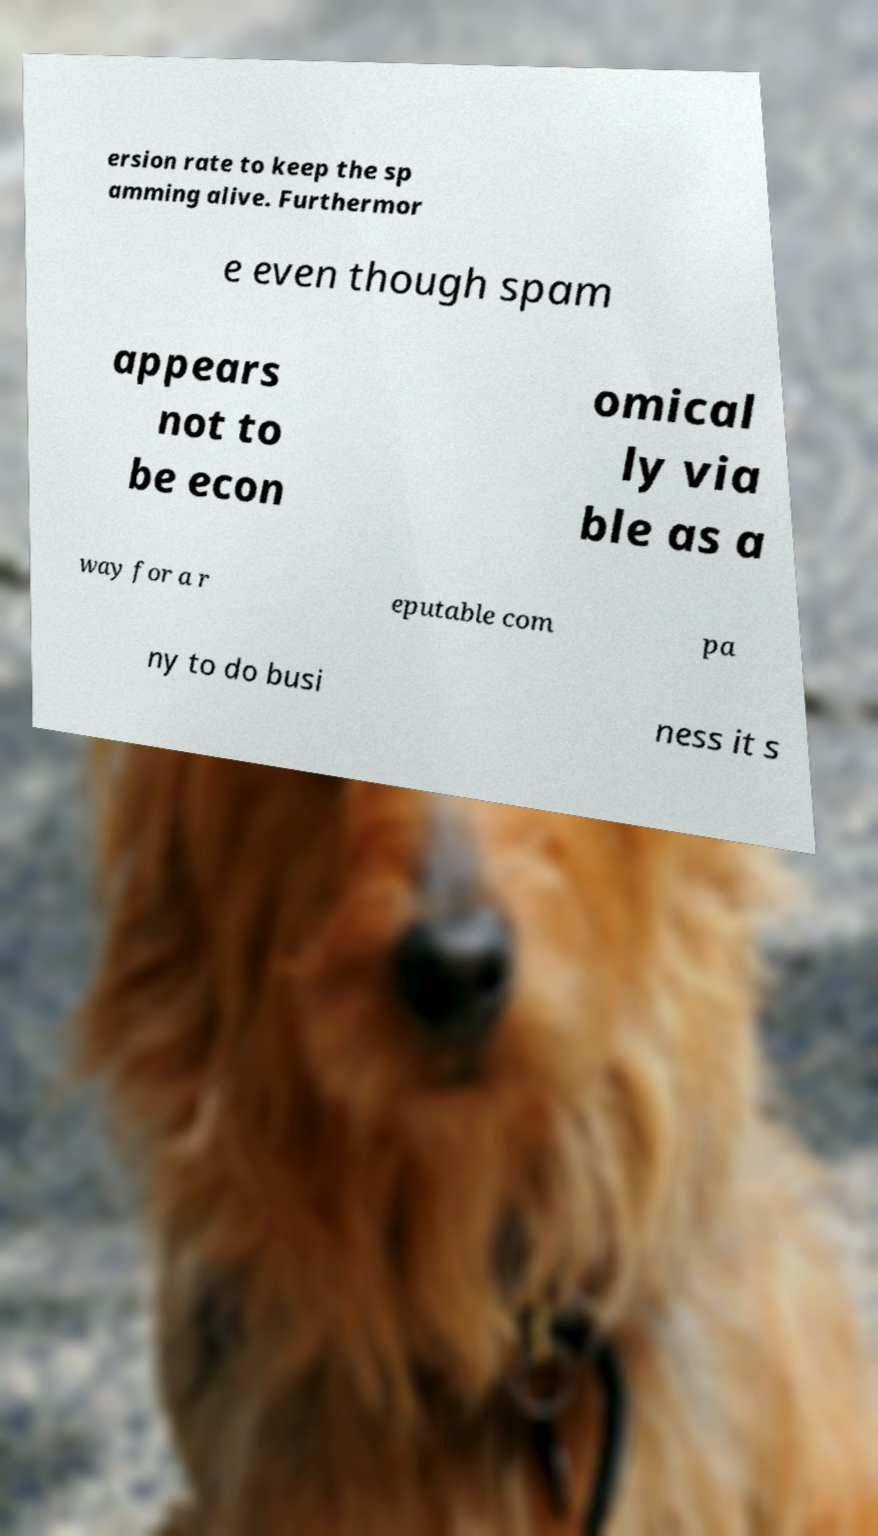Can you read and provide the text displayed in the image?This photo seems to have some interesting text. Can you extract and type it out for me? ersion rate to keep the sp amming alive. Furthermor e even though spam appears not to be econ omical ly via ble as a way for a r eputable com pa ny to do busi ness it s 